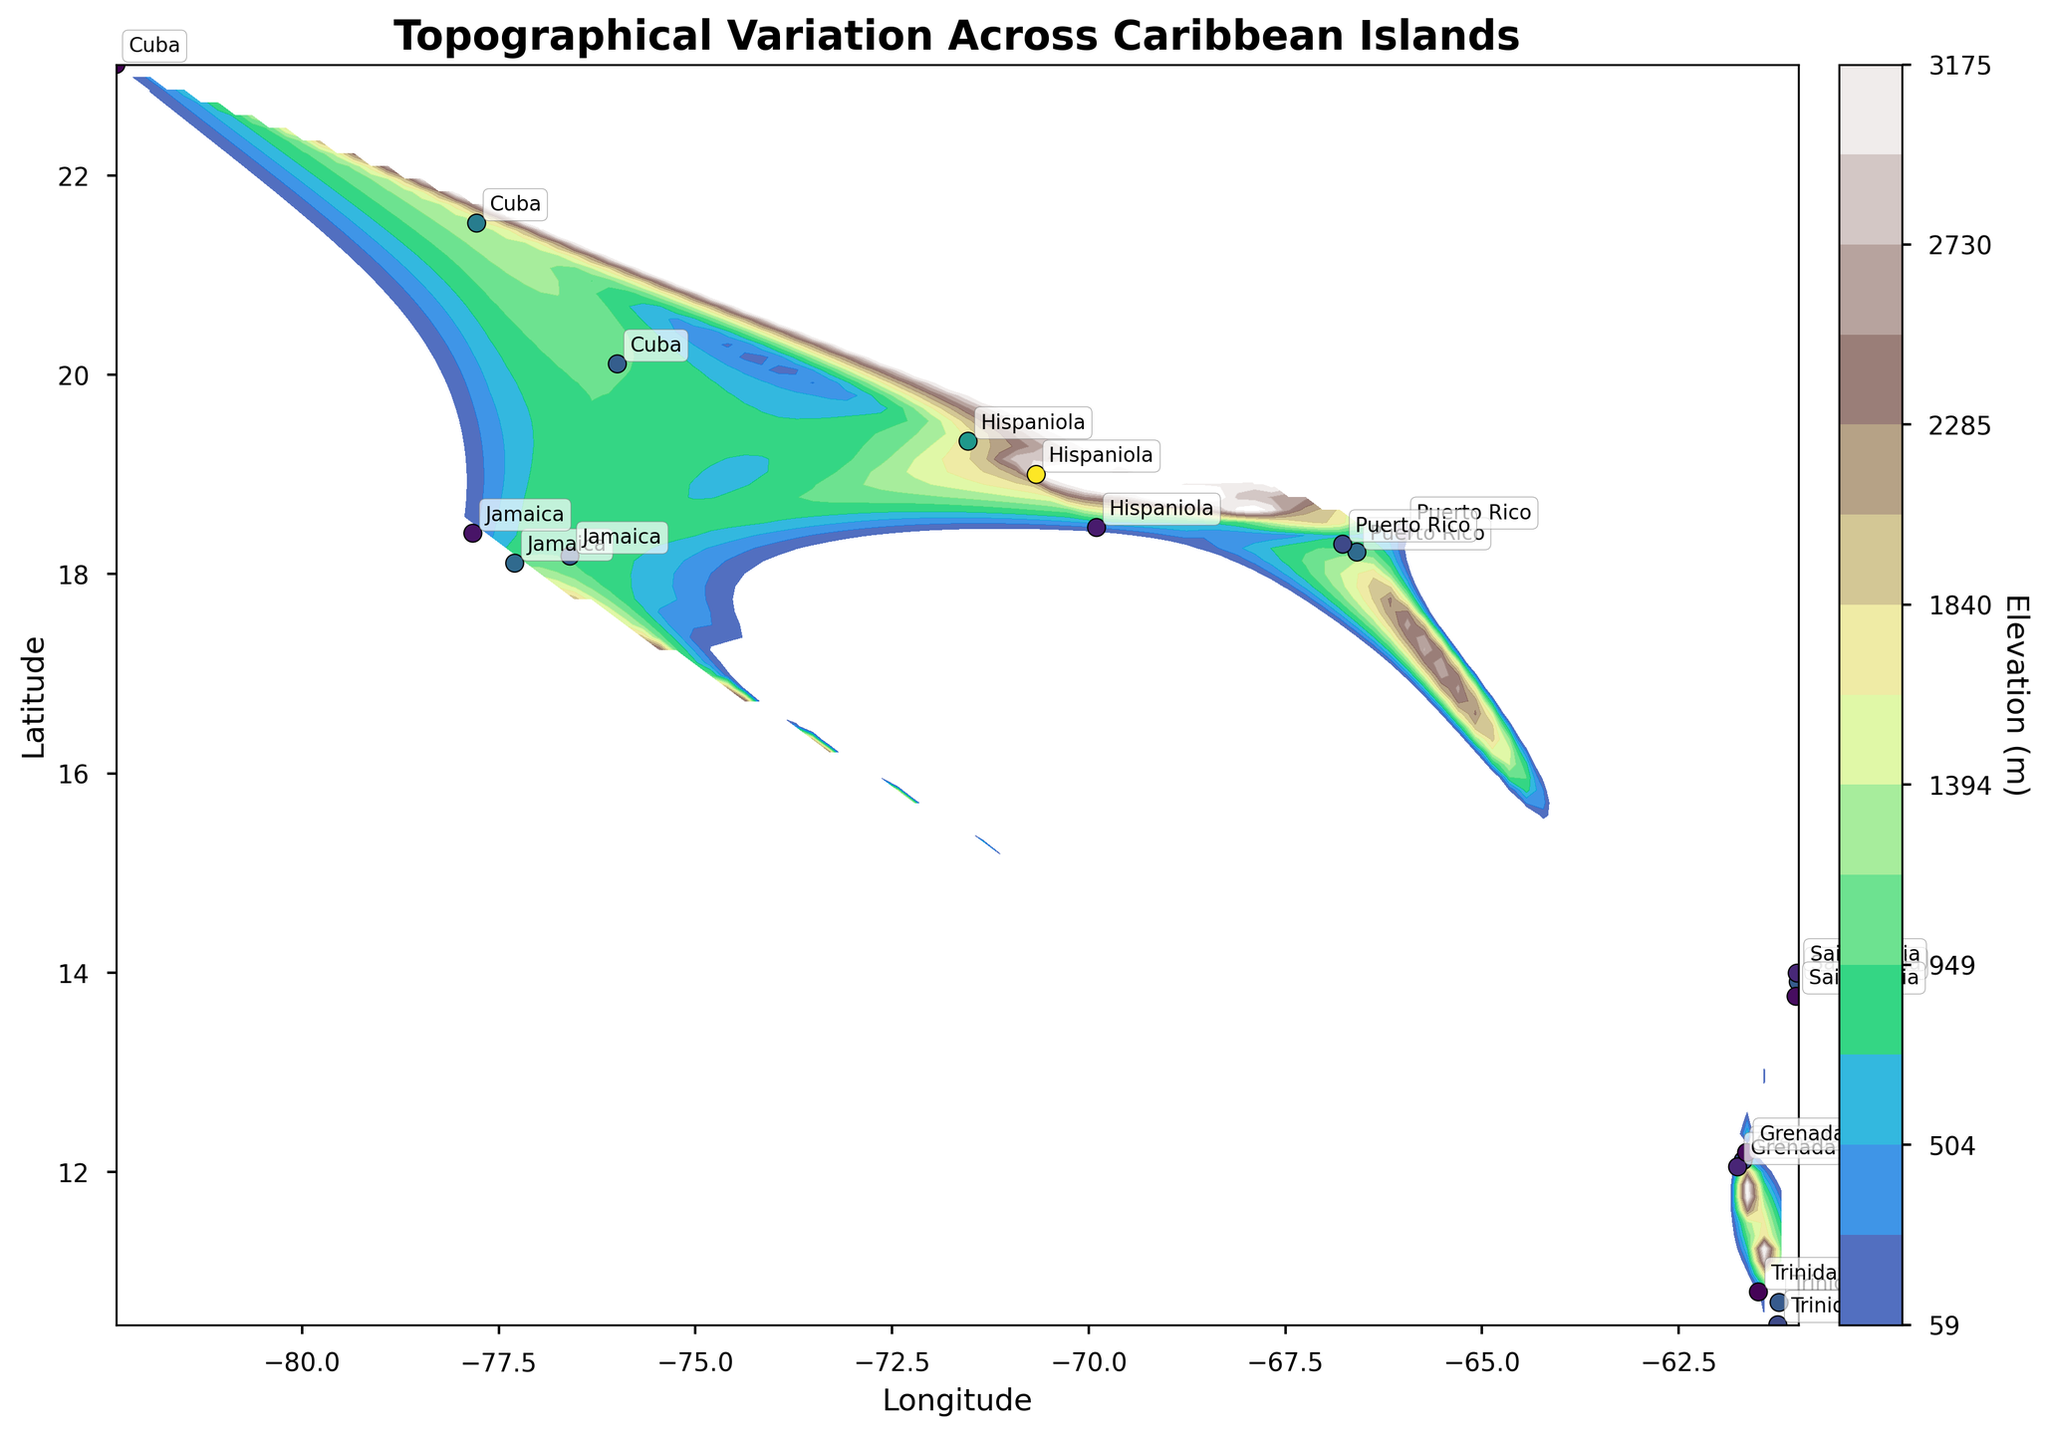What is the title of the figure? The title is usually displayed at the top of the figure and provides an overview of what the figure is about. Here, the title states the subject of the plot related to topographical variation across Caribbean islands.
Answer: Topographical Variation Across Caribbean Islands How many unique islands are labeled in the figure? The islands are labeled by their names on the plot. Count the different island names annotated across the plot.
Answer: 7 Which island has the highest elevation point according to the plot? Examine the color-coded elevations and the annotation for the highest elevation point on the plot. Hispaniola stands out with the highest peak based on the contour colors and the labels.
Answer: Hispaniola What is the elevation of the lowest point found in Cuba, and where is it located? Identify the data points belonging to Cuba and find the lowest elevation value among them by referring to the color scale and the corresponding annotations. The lowest elevation point in Cuba is 59 meters, located at (23.1136, -82.3666).
Answer: 59 meters at (23.1136, -82.3666) Which islands have elevation points above 1000 meters? Evaluate the islands with labeled data points and check which ones have elevations over 1000 meters by looking at the color scale and annotations on the plot.
Answer: Jamaica, Puerto Rico, Hispaniola, Cuba Compare the average elevation of Trinidad and Grenada. Which island has a higher average elevation? Calculate the average elevation of both islands by summing their respective elevation values and dividing by the number of points for each island. Trinidad has elevation points of 940, 754, and 85, while Grenada has 840, 378, and 119. Average elevation of Trinidad is (940 + 754 + 85)/3 ≈ 593 meters and for Grenada is (840 + 378 + 119)/3 ≈ 445.7 meters. Hence, Trinidad has a higher average.
Answer: Trinidad Which island has the steepest elevation gradient on the plot? The steepest elevation gradient will be indicated by the closest contour lines. Identify the area where contour lines are most tightly packed and reference the island name in the annotation. Hispaniola typically shows the steepest gradient.
Answer: Hispaniola How does the elevation at the easternmost point of Puerto Rico compare to the westernmost point of Jamaica? Identify the easternmost point of Puerto Rico and the westernmost point of Jamaica on the plot, then compare their elevation values based on the color scale and annotations. Puerto Rico's point is at (18.4285, -65.9911) with 236 meters and Jamaica's at (18.4101, -77.8296) with 225 meters.
Answer: Puerto Rico's easternmost point is slightly higher 